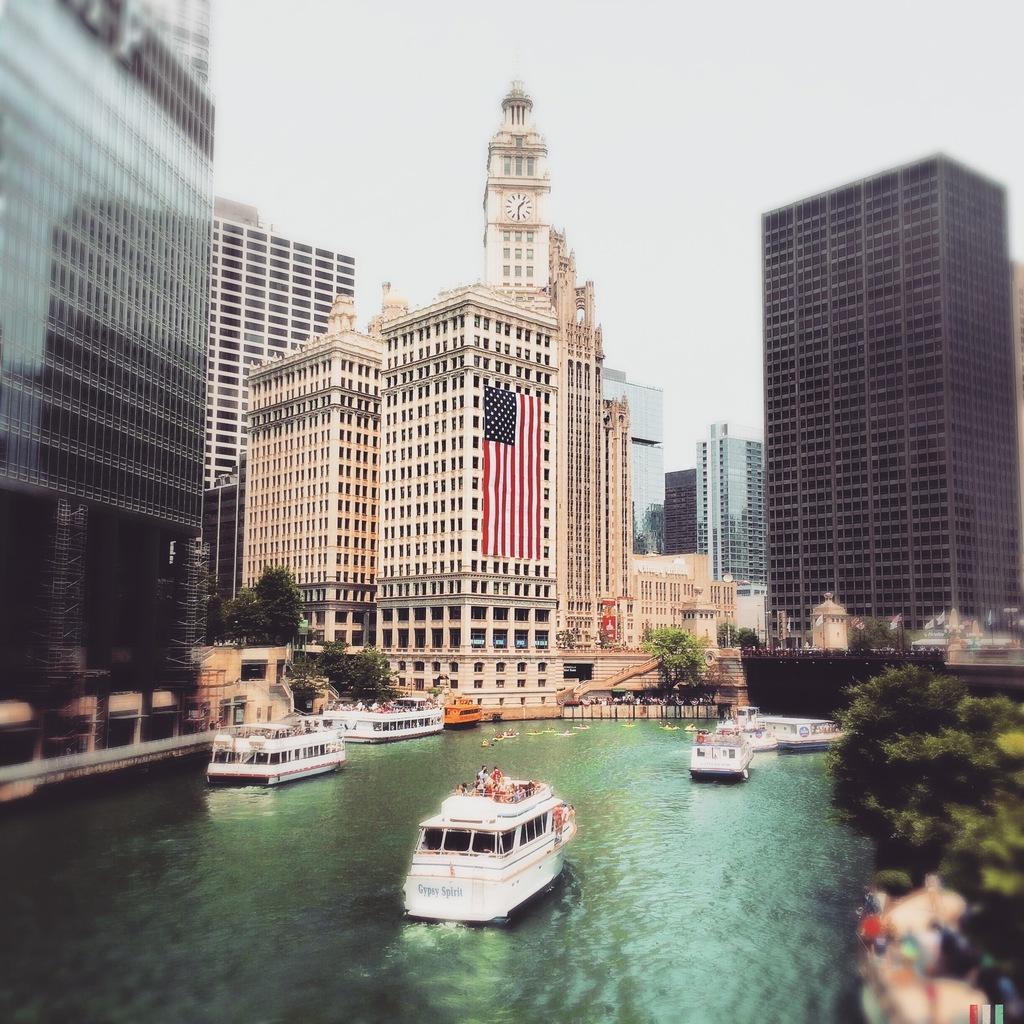Please provide a concise description of this image. In this image we can see the ships on the water and there are persons sitting on the ship. And at the back we can see the buildings and a flag attached to the building. There are trees and the sky. 